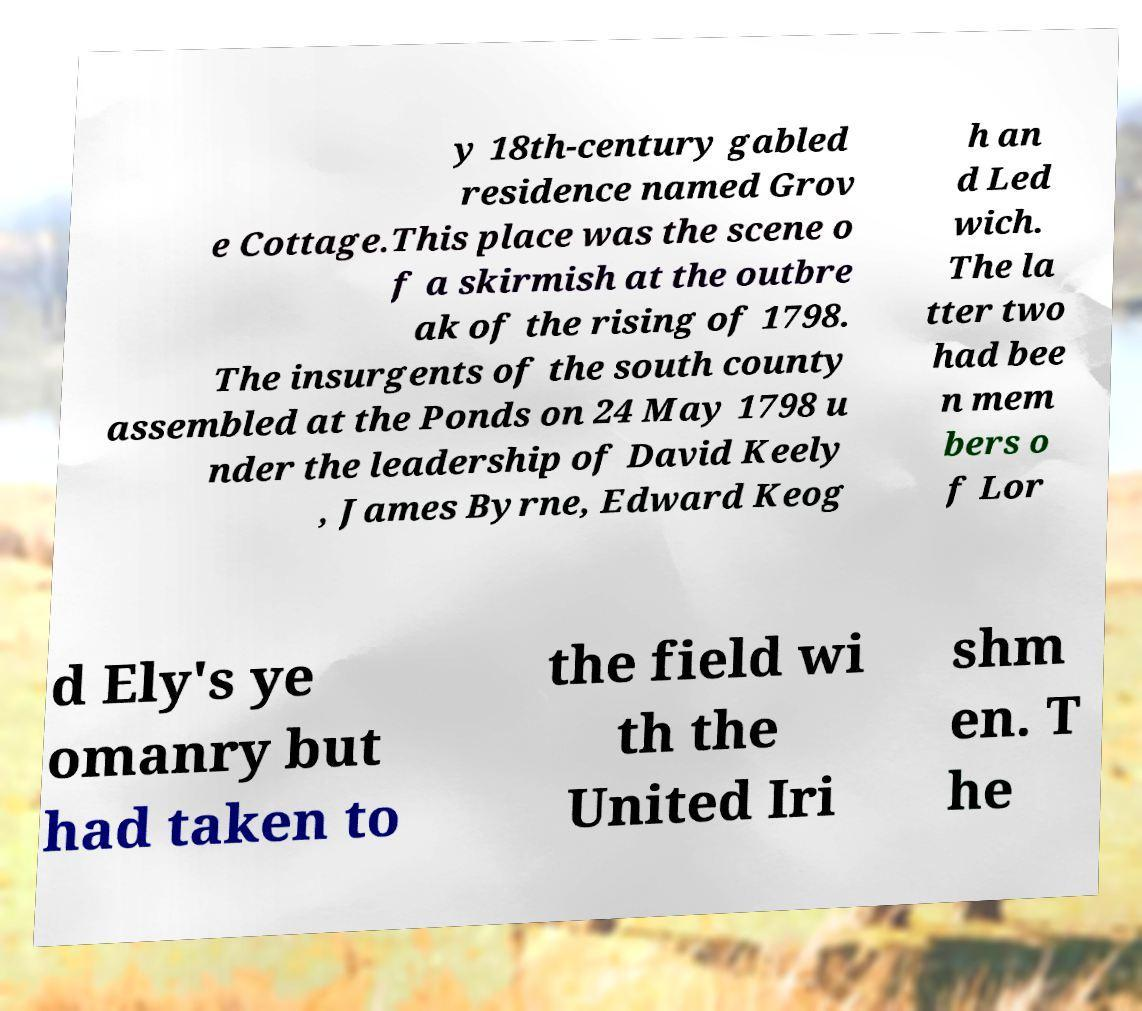For documentation purposes, I need the text within this image transcribed. Could you provide that? y 18th-century gabled residence named Grov e Cottage.This place was the scene o f a skirmish at the outbre ak of the rising of 1798. The insurgents of the south county assembled at the Ponds on 24 May 1798 u nder the leadership of David Keely , James Byrne, Edward Keog h an d Led wich. The la tter two had bee n mem bers o f Lor d Ely's ye omanry but had taken to the field wi th the United Iri shm en. T he 